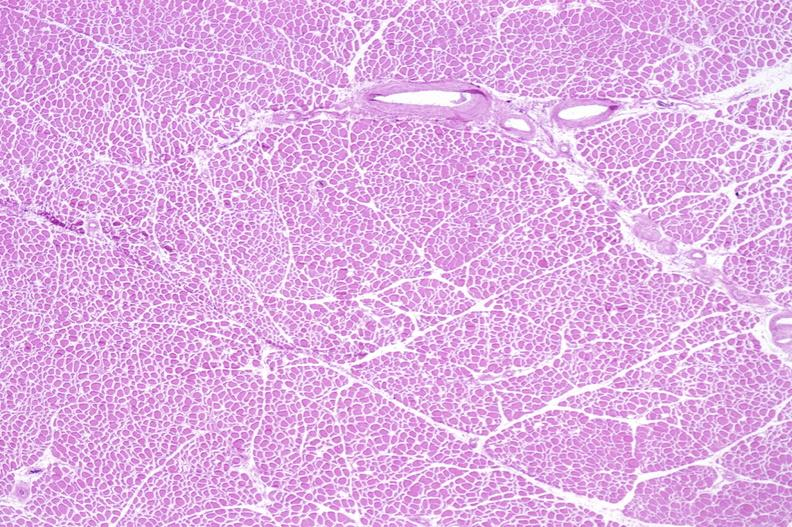what does this image show?
Answer the question using a single word or phrase. Skeletal muscle atrophy 